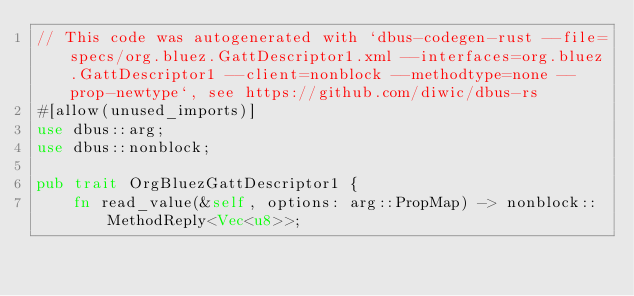Convert code to text. <code><loc_0><loc_0><loc_500><loc_500><_Rust_>// This code was autogenerated with `dbus-codegen-rust --file=specs/org.bluez.GattDescriptor1.xml --interfaces=org.bluez.GattDescriptor1 --client=nonblock --methodtype=none --prop-newtype`, see https://github.com/diwic/dbus-rs
#[allow(unused_imports)]
use dbus::arg;
use dbus::nonblock;

pub trait OrgBluezGattDescriptor1 {
    fn read_value(&self, options: arg::PropMap) -> nonblock::MethodReply<Vec<u8>>;</code> 